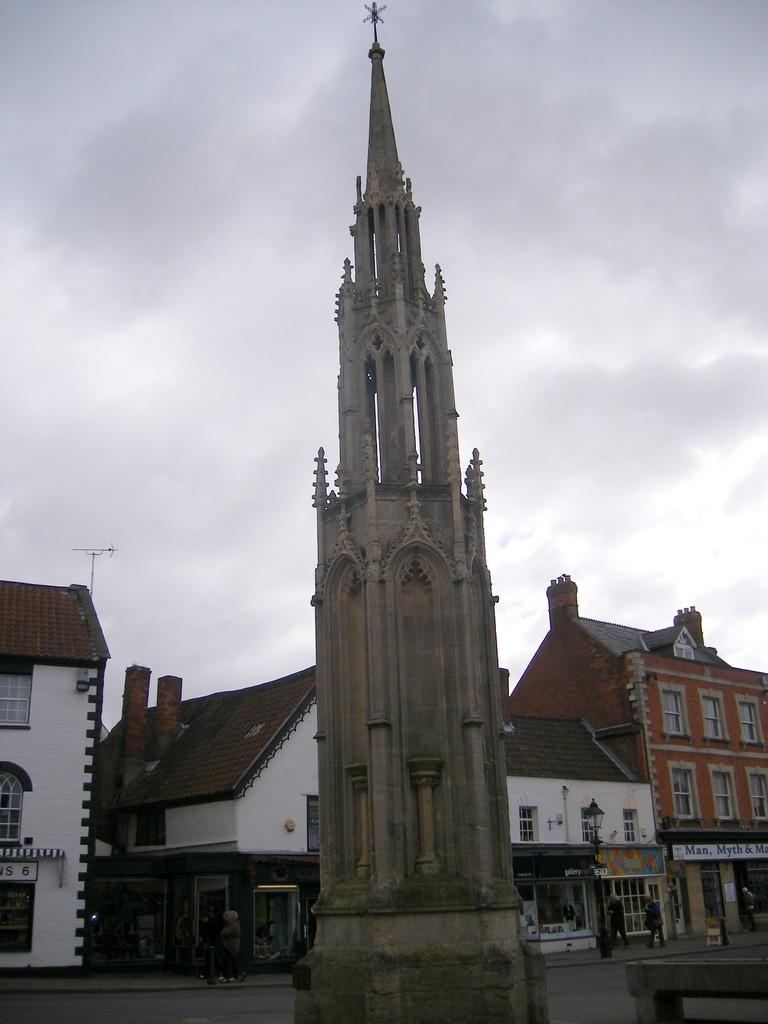What type of structures are present in the image? The image contains buildings. Can you describe the prominent feature in the front of the image? There is a tower in the front of the image. What is located at the bottom of the image? There is a road at the bottom of the image. What can be seen at the top of the image? The sky is visible at the top of the image. What is the condition of the sky in the image? Clouds are present in the sky. What type of hobbies can be seen being practiced by the clouds in the image? There are no hobbies being practiced by the clouds in the image, as clouds do not engage in human activities. Can you tell me how many rifles are visible in the image? There are no rifles present in the image; it features buildings, a tower, a road, and clouds in the sky. 